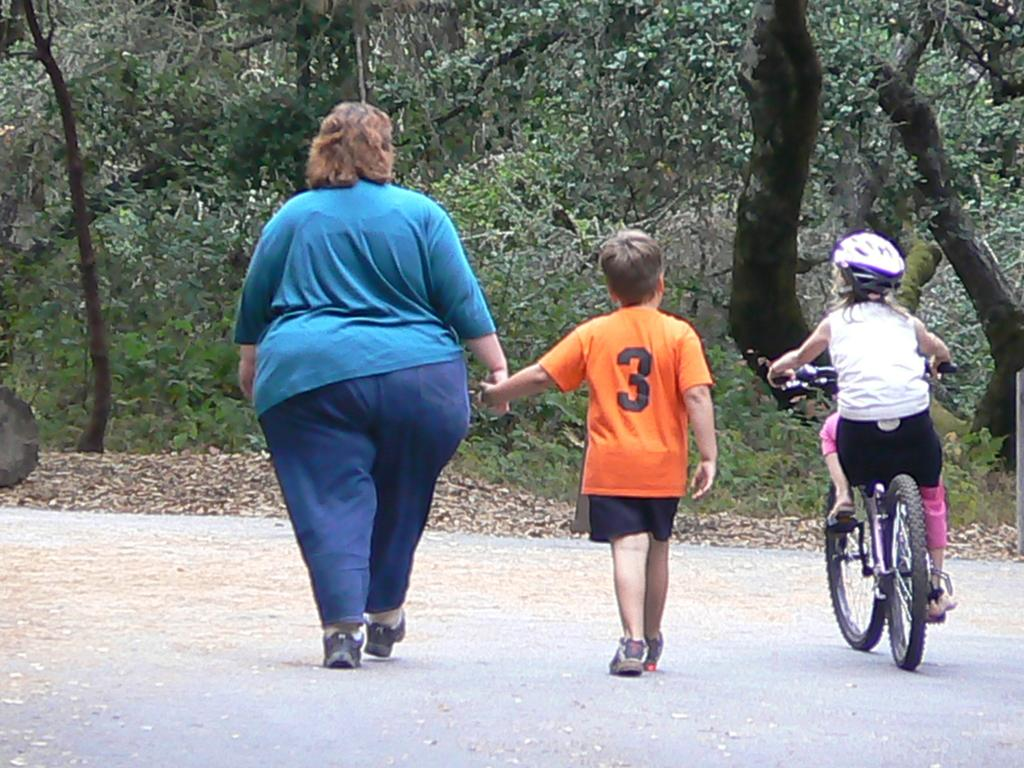How many people are on the ground in the image? There are two people on the ground in the image. What is the kid doing in the image? The kid is riding a bicycle in the image. What can be seen in the background of the image? There are trees in the background of the image. What is covering the ground in the image? Dry leaves are present on the ground in the image. What type of arithmetic problem is the kid solving on the bicycle? There is no indication in the image that the kid is solving an arithmetic problem; they are simply riding a bicycle. 